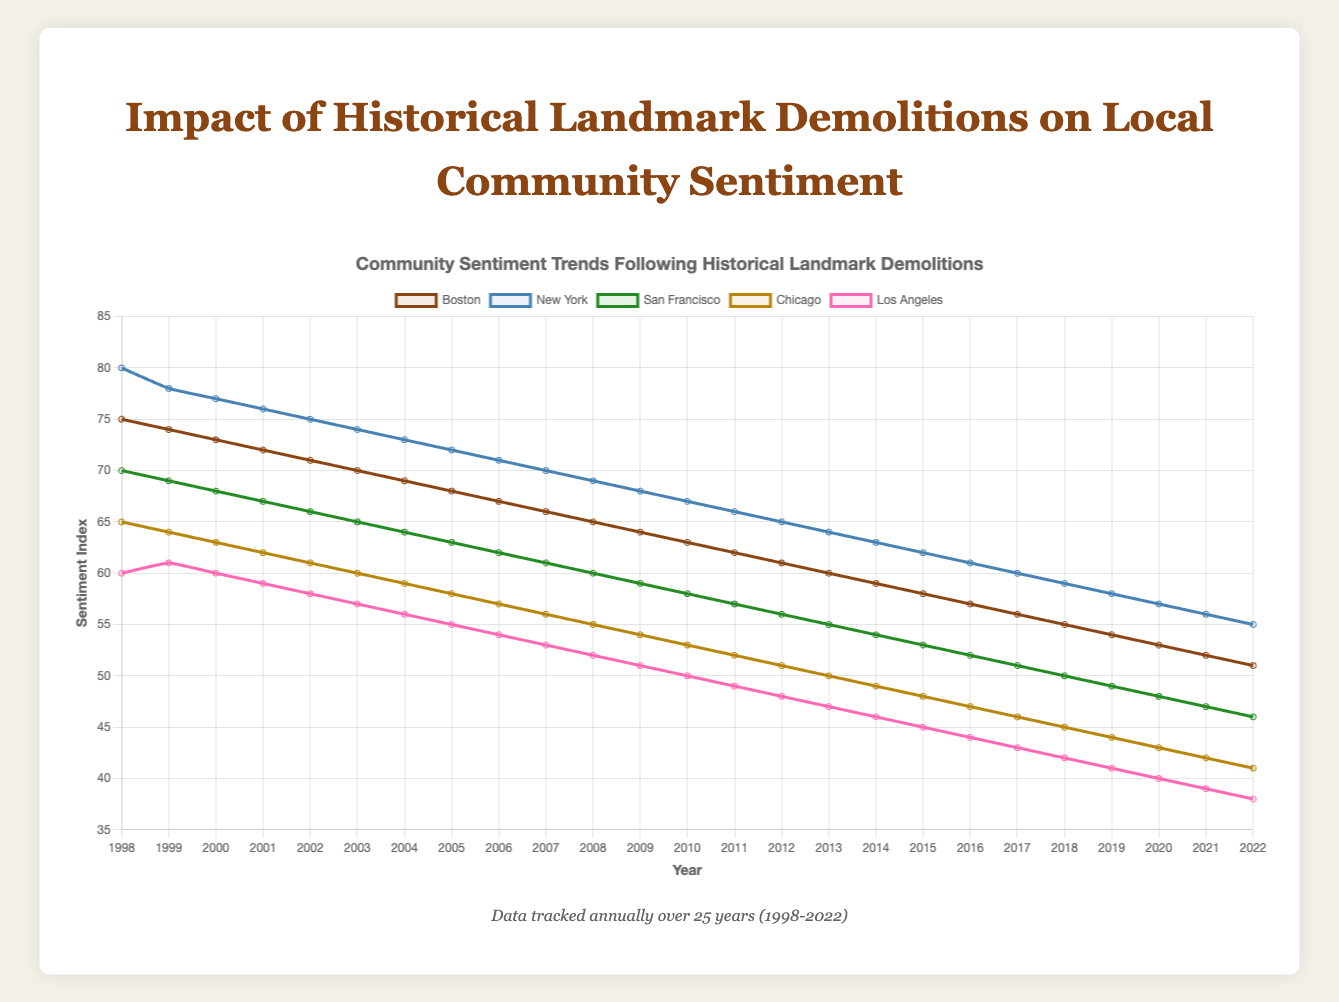What is the trend of the SentimentIndex for Boston over 25 years? Over the 25 years, the SentimentIndex for Boston shows a steady decline from 75 in 1998 to 51 in 2022.
Answer: Steady decline Which city had the highest SentimentIndex in 1998? By observing the starting point of each line in the chart, New York had the highest SentimentIndex in 1998 at 80.
Answer: New York In 2022, which city had the lowest SentimentIndex? By comparing the ending points of the lines on the chart, Los Angeles had the lowest SentimentIndex in 2022 at 38.
Answer: Los Angeles By how much did the SentimentIndex for San Francisco decrease from 1998 to 2022? The SentimentIndex for San Francisco was 70 in 1998 and decreased to 46 in 2022. The decrease is 70 - 46 = 24.
Answer: 24 Which city's SentimentIndex decreased the most from 1998 to 2022? To find this, calculate the difference in SentimentIndex for each city from 1998 to 2022 and compare:
Boston: 75 - 51 = 24,
New York: 80 - 55 = 25,
San Francisco: 70 - 46 = 24,
Chicago: 65 - 41 = 24,
Los Angeles: 60 - 38 = 22.
New York has the largest decrease of 25 points.
Answer: New York Between which two consecutive years did Chicago experience the largest drop in SentimentIndex? By looking at the slope between consecutive data points, the largest drop is between 1999 and 2000 where the SentimentIndex drops from 64 to 63, a drop of 1. Comparing further, the largest drop is actually between 2020 and 2021, where it drops from 43 to 42, which is a drop of 1 point.
Answer: 2020 to 2021 What is the average SentimentIndex for Boston over the 25 years? Sum up the SentimentIndex values for Boston over the 25 years and divide by 25 => (75+74+73+72+71+70+69+68+67+66+65+64+63+62+61+60+59+58+57+56+55+54+53+52+51)/25 = 63.
Answer: 63 Which city had the smallest decline in SentimentIndex from 1998 to 2022? Calculate the difference for each city:
Boston: 75 - 51 = 24,
New York: 80 - 55 = 25,
San Francisco: 70 - 46 = 24,
Chicago: 65 - 41 = 24,
Los Angeles: 60 - 38 = 22.
Los Angeles had the smallest decline of 22 points.
Answer: Los Angeles In 2010, which city had the highest SentimentIndex? By observing the chart data for 2010, New York had the highest SentimentIndex at 67.
Answer: New York 